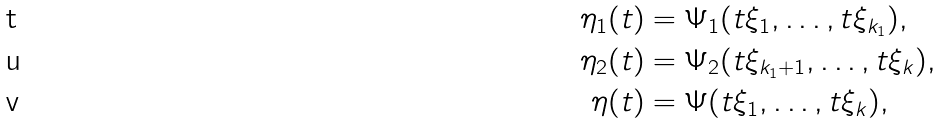<formula> <loc_0><loc_0><loc_500><loc_500>\eta _ { 1 } ( t ) & = \Psi _ { 1 } ( t \xi _ { 1 } , \dots , t \xi _ { k _ { 1 } } ) , \\ \eta _ { 2 } ( t ) & = \Psi _ { 2 } ( t \xi _ { k _ { 1 } + 1 } , \dots , t \xi _ { k } ) , \\ \eta ( t ) & = \Psi ( t \xi _ { 1 } , \dots , t \xi _ { k } ) ,</formula> 